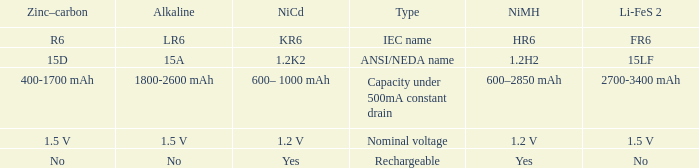What is NiCd, when Type is "Capacity under 500mA constant Drain"? 600– 1000 mAh. 